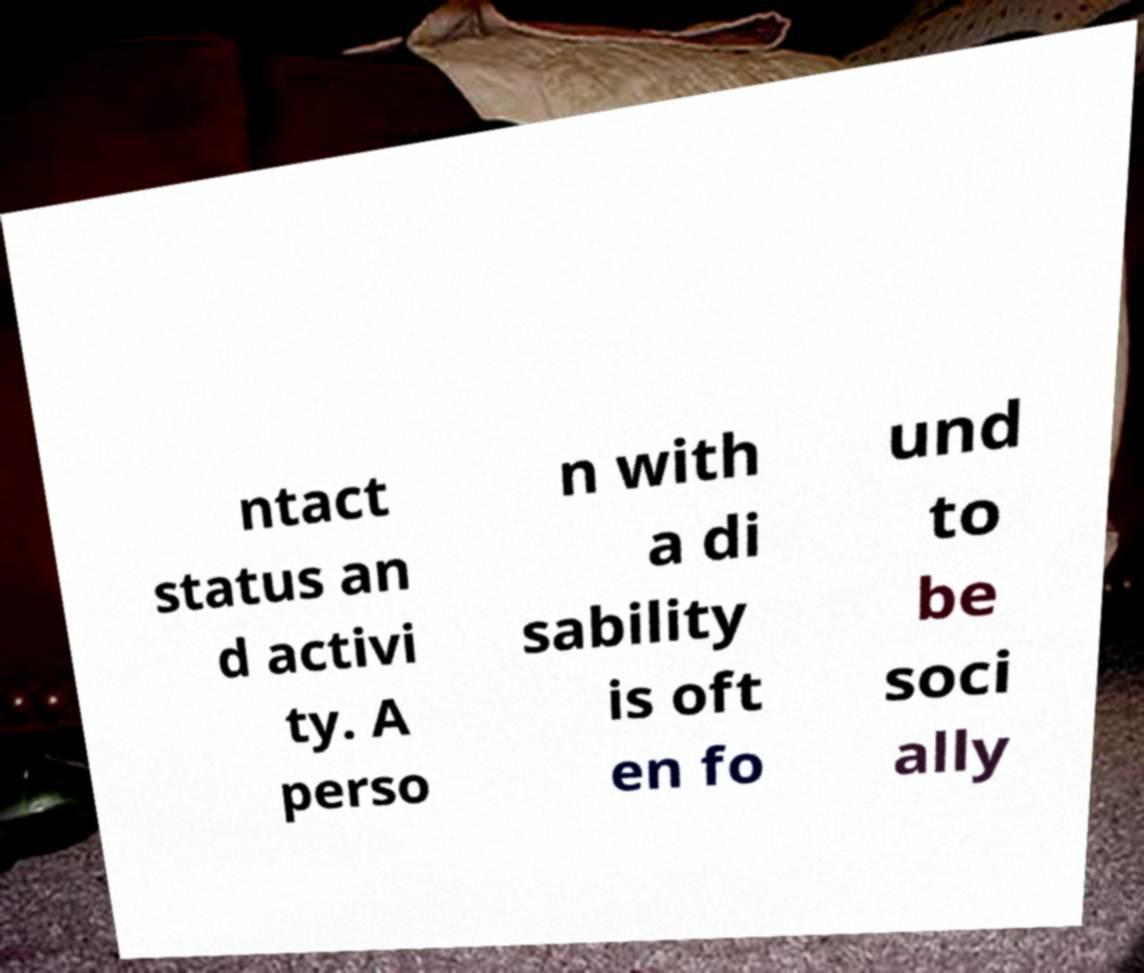Can you read and provide the text displayed in the image?This photo seems to have some interesting text. Can you extract and type it out for me? ntact status an d activi ty. A perso n with a di sability is oft en fo und to be soci ally 